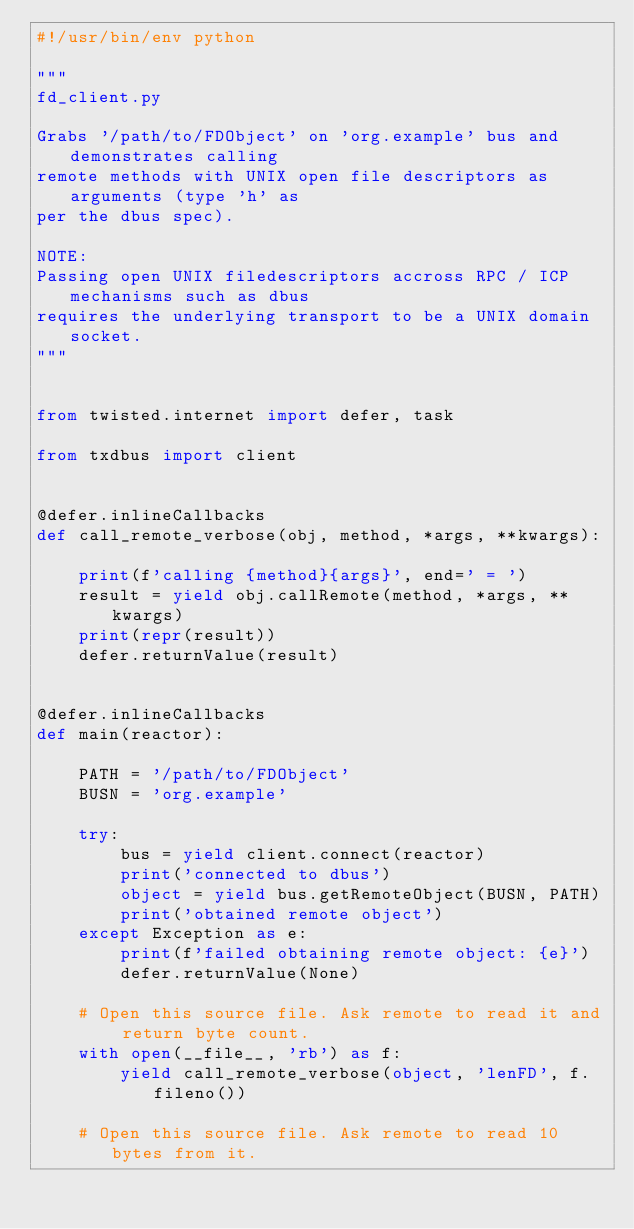Convert code to text. <code><loc_0><loc_0><loc_500><loc_500><_Python_>#!/usr/bin/env python

"""
fd_client.py

Grabs '/path/to/FDObject' on 'org.example' bus and demonstrates calling
remote methods with UNIX open file descriptors as arguments (type 'h' as
per the dbus spec).

NOTE:
Passing open UNIX filedescriptors accross RPC / ICP mechanisms such as dbus
requires the underlying transport to be a UNIX domain socket.
"""


from twisted.internet import defer, task

from txdbus import client


@defer.inlineCallbacks
def call_remote_verbose(obj, method, *args, **kwargs):

    print(f'calling {method}{args}', end=' = ')
    result = yield obj.callRemote(method, *args, **kwargs)
    print(repr(result))
    defer.returnValue(result)


@defer.inlineCallbacks
def main(reactor):

    PATH = '/path/to/FDObject'
    BUSN = 'org.example'

    try:
        bus = yield client.connect(reactor)
        print('connected to dbus')
        object = yield bus.getRemoteObject(BUSN, PATH)
        print('obtained remote object')
    except Exception as e:
        print(f'failed obtaining remote object: {e}')
        defer.returnValue(None)

    # Open this source file. Ask remote to read it and return byte count.
    with open(__file__, 'rb') as f:
        yield call_remote_verbose(object, 'lenFD', f.fileno())

    # Open this source file. Ask remote to read 10 bytes from it.</code> 